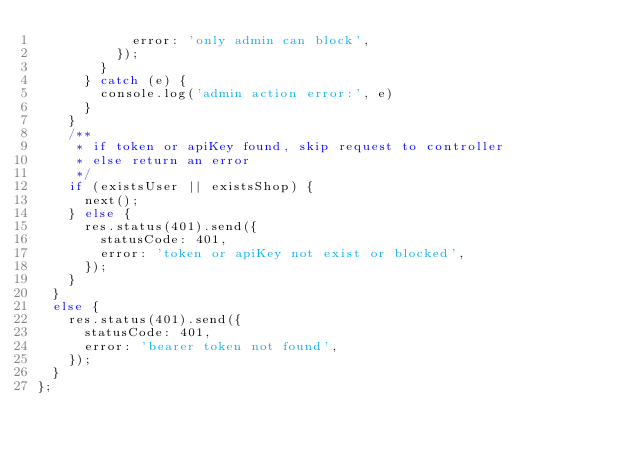Convert code to text. <code><loc_0><loc_0><loc_500><loc_500><_TypeScript_>            error: 'only admin can block',
          });
        }
      } catch (e) {
        console.log('admin action error:', e)
      }
    }
    /**
     * if token or apiKey found, skip request to controller
     * else return an error
     */
    if (existsUser || existsShop) {
      next();
    } else {
      res.status(401).send({
        statusCode: 401,
        error: 'token or apiKey not exist or blocked',
      });
    }
  }
  else {
    res.status(401).send({
      statusCode: 401,
      error: 'bearer token not found',
    });
  }
};
</code> 